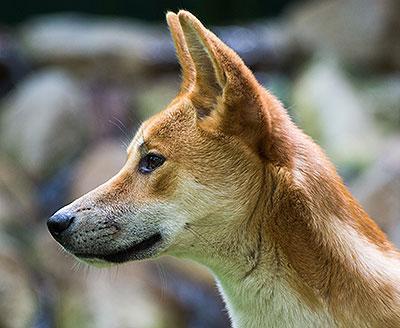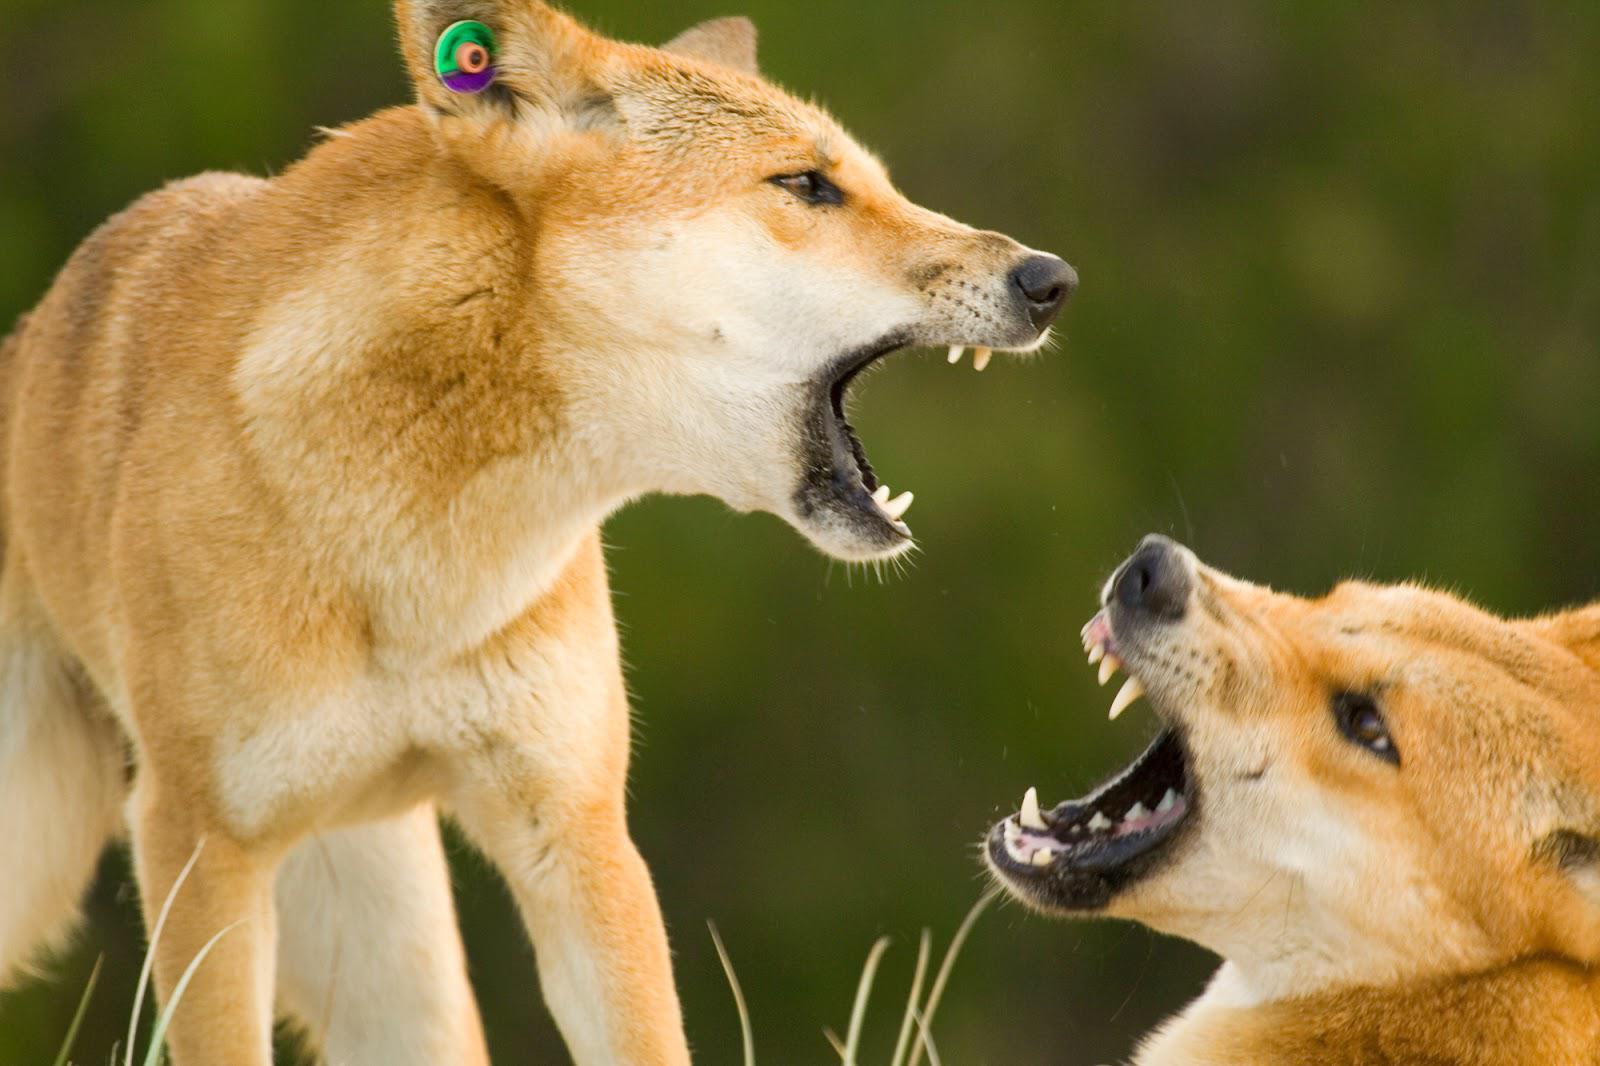The first image is the image on the left, the second image is the image on the right. Considering the images on both sides, is "Some of the dingoes are howling." valid? Answer yes or no. No. The first image is the image on the left, the second image is the image on the right. Evaluate the accuracy of this statement regarding the images: "An image contains at least two canines.". Is it true? Answer yes or no. Yes. 